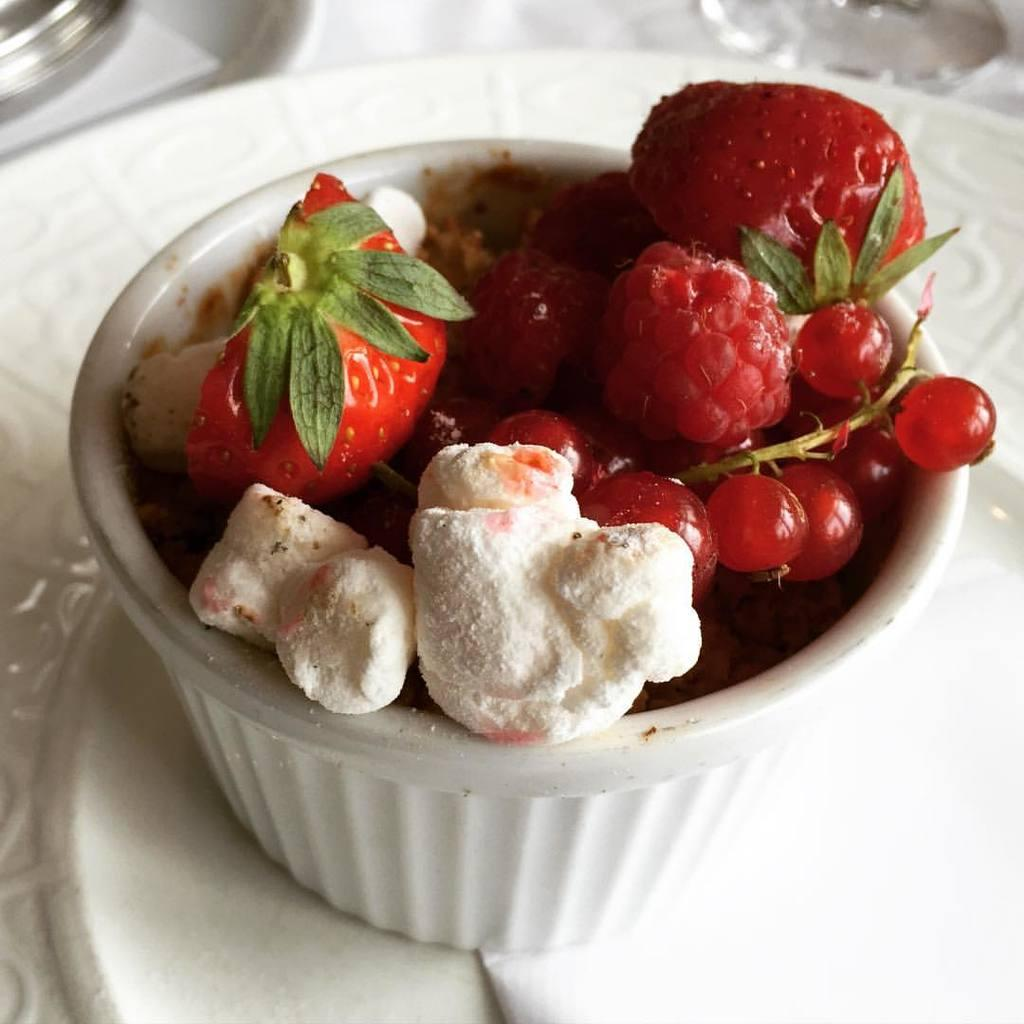What is in the bowl that is visible in the image? There is food in a bowl in the image. What other items can be seen on the table in the image? There are plates, a glass, and another bowl visible in the image. What might be used for cleaning or wiping in the image? A tissue is present in the image for cleaning or wiping. How is the table in the image covered? The table in the image is covered with a white cloth. How many trees can be seen growing through the table in the image? There are no trees visible in the image, and none are growing through the table. 